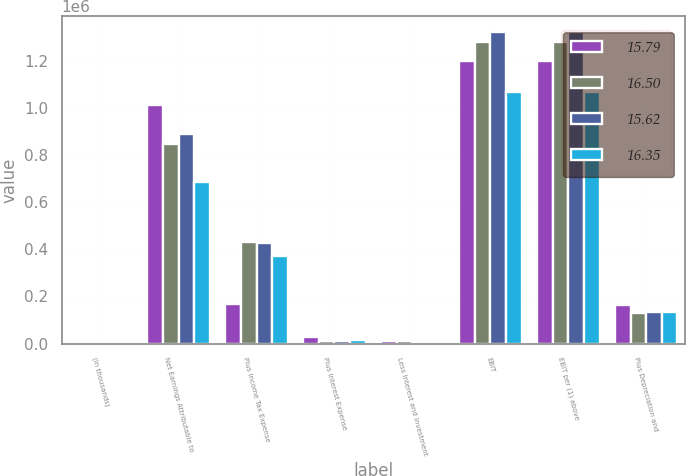Convert chart to OTSL. <chart><loc_0><loc_0><loc_500><loc_500><stacked_bar_chart><ecel><fcel>(in thousands)<fcel>Net Earnings Attributable to<fcel>Plus Income Tax Expense<fcel>Plus Interest Expense<fcel>Less Interest and Investment<fcel>EBIT<fcel>EBIT per (1) above<fcel>Plus Depreciation and<nl><fcel>15.79<fcel>2018<fcel>1.01214e+06<fcel>168702<fcel>26494<fcel>8857<fcel>1.19848e+06<fcel>1.19848e+06<fcel>161858<nl><fcel>16.5<fcel>2017<fcel>846735<fcel>431542<fcel>12683<fcel>10859<fcel>1.2801e+06<fcel>1.2801e+06<fcel>130977<nl><fcel>15.62<fcel>2016<fcel>890052<fcel>426698<fcel>12871<fcel>6191<fcel>1.32343e+06<fcel>1.32343e+06<fcel>131968<nl><fcel>16.35<fcel>2015<fcel>686088<fcel>369879<fcel>13111<fcel>2934<fcel>1.06614e+06<fcel>1.06614e+06<fcel>133434<nl></chart> 